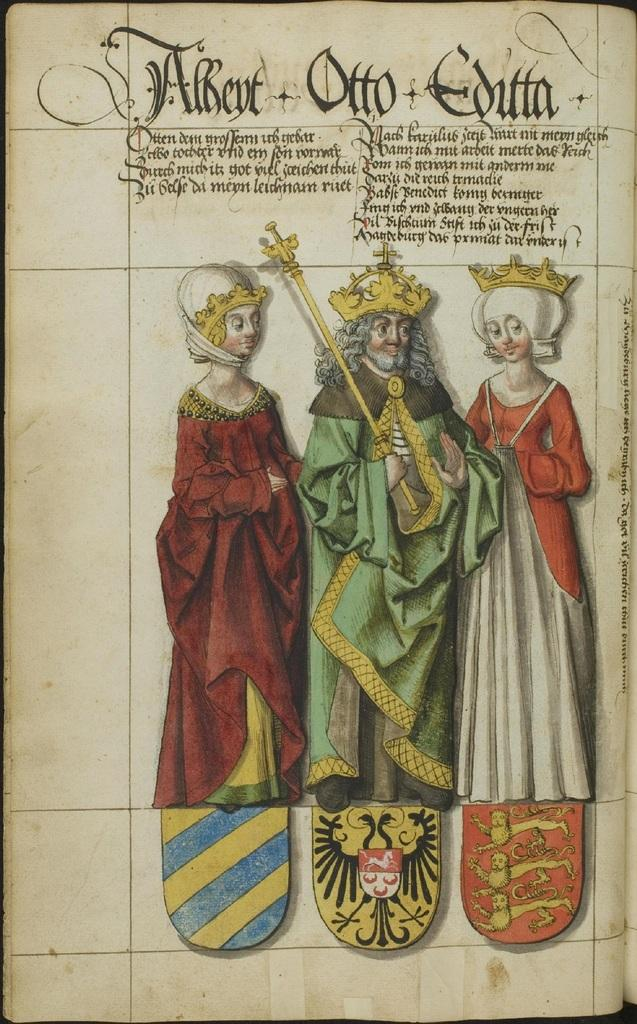What can be seen in the image that represents human figures? There are depictions of people in the image. What else is present on the image besides the depictions of people? There is text on the image. What type of veil is worn by the people in the image? There is no indication of any veils being worn by the people in the image. What type of utensil is used by the people in the image? There is no utensil, such as a fork, present in the image. 